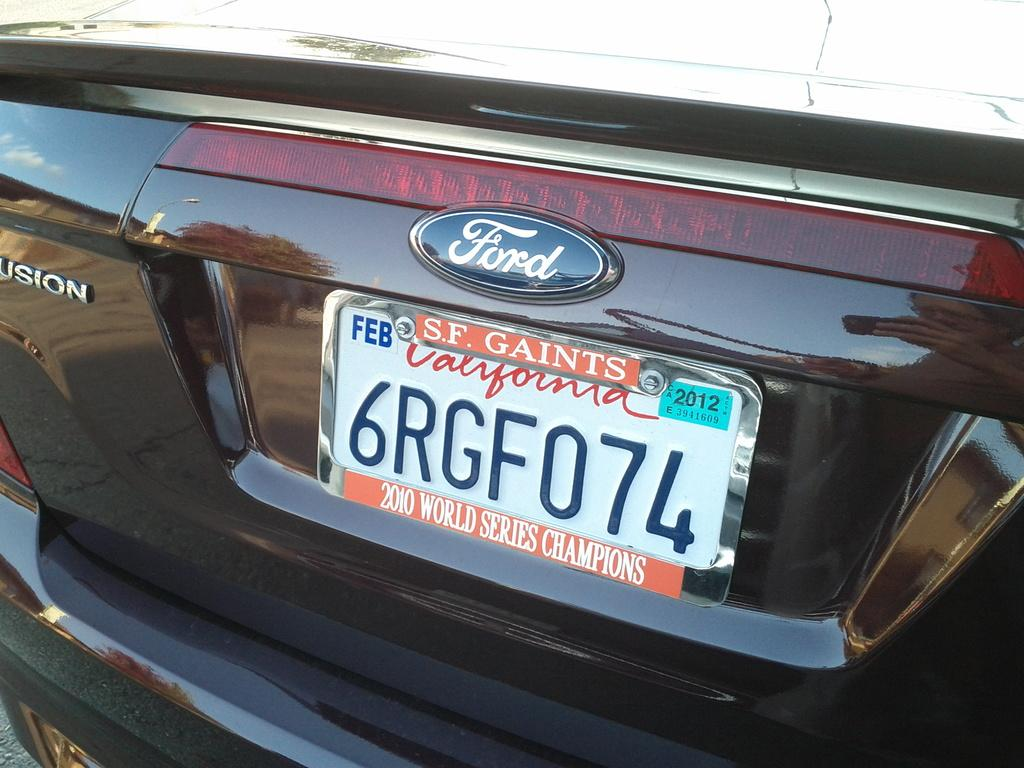<image>
Offer a succinct explanation of the picture presented. A white car license plate that is from California 